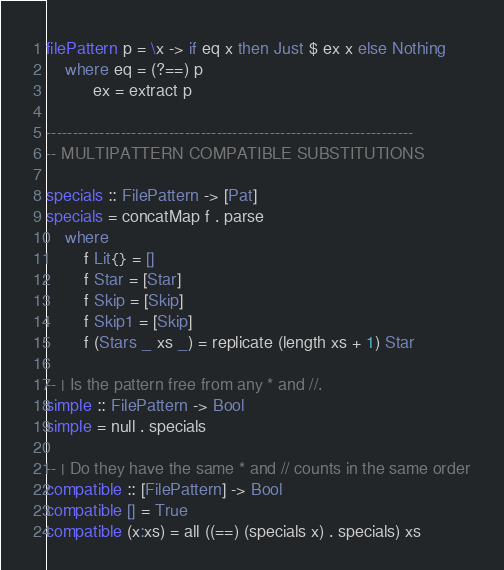<code> <loc_0><loc_0><loc_500><loc_500><_Haskell_>filePattern p = \x -> if eq x then Just $ ex x else Nothing
    where eq = (?==) p
          ex = extract p

---------------------------------------------------------------------
-- MULTIPATTERN COMPATIBLE SUBSTITUTIONS

specials :: FilePattern -> [Pat]
specials = concatMap f . parse
    where
        f Lit{} = []
        f Star = [Star]
        f Skip = [Skip]
        f Skip1 = [Skip]
        f (Stars _ xs _) = replicate (length xs + 1) Star

-- | Is the pattern free from any * and //.
simple :: FilePattern -> Bool
simple = null . specials

-- | Do they have the same * and // counts in the same order
compatible :: [FilePattern] -> Bool
compatible [] = True
compatible (x:xs) = all ((==) (specials x) . specials) xs
</code> 